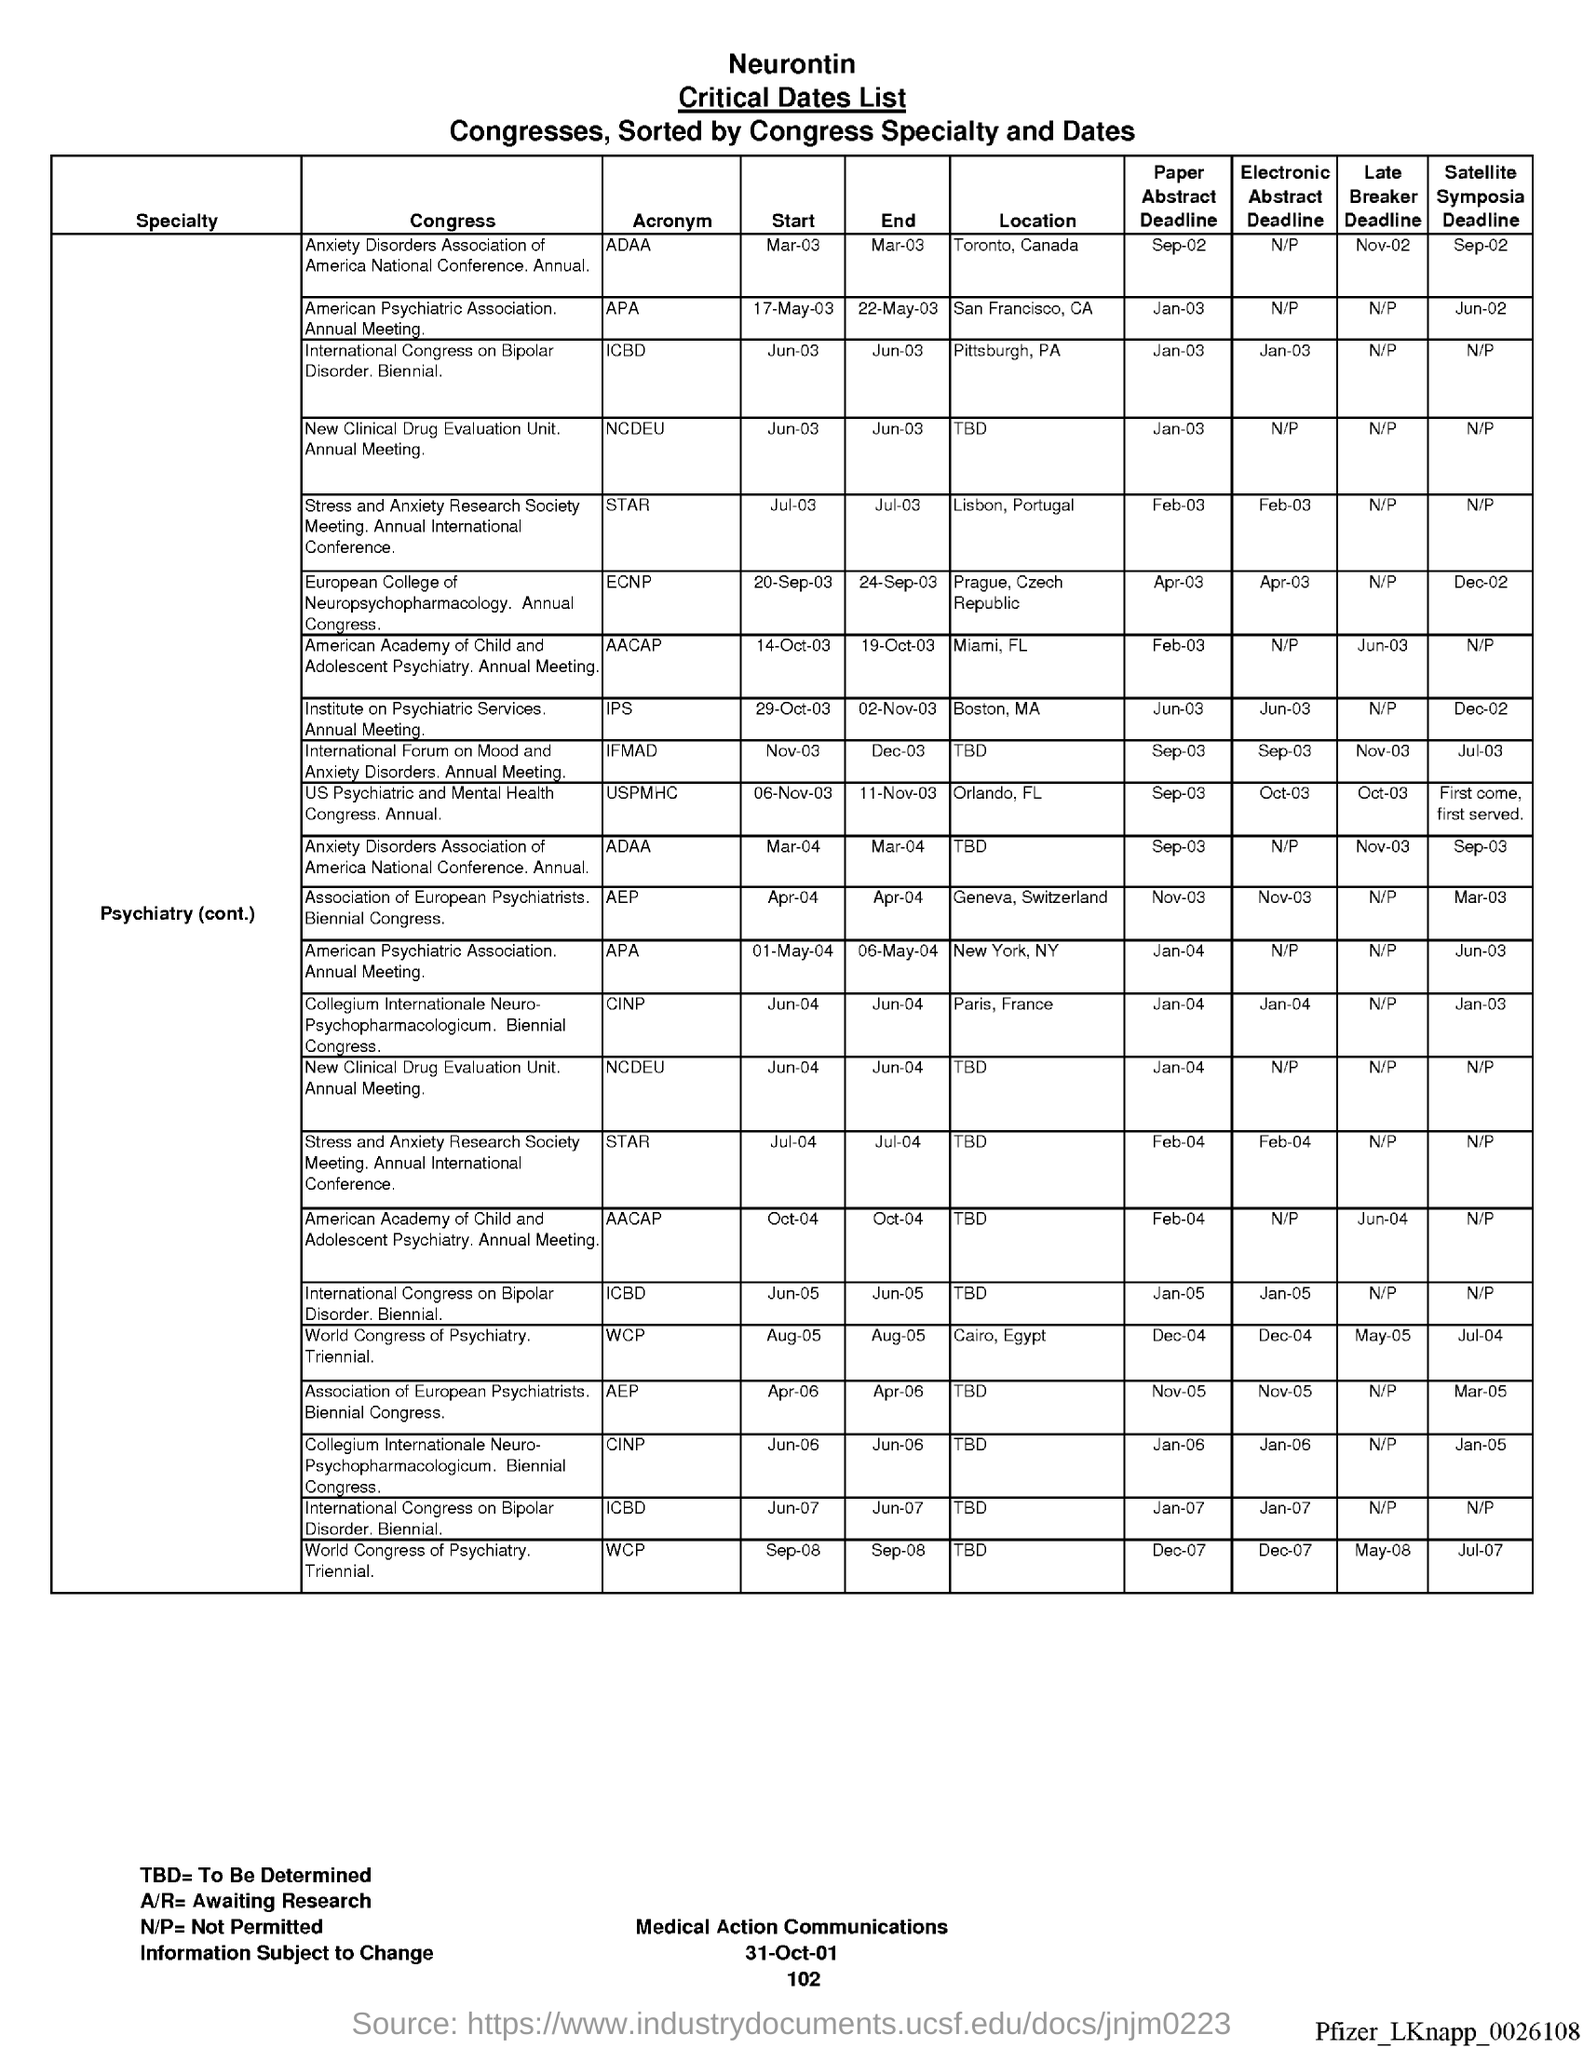Point out several critical features in this image. The page number for the date of 102 is... A/R equals, pending research. What is TBD equal to? It remains to be determined. The date at the bottom of the page is 31 October 2001. The ratio of N to P, denoted as N/P, is not permitted. 